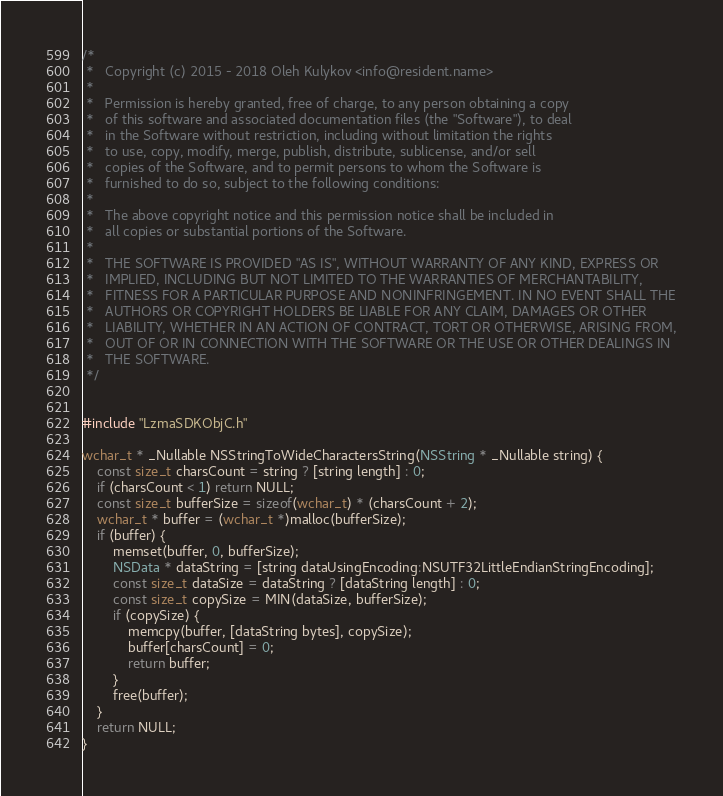<code> <loc_0><loc_0><loc_500><loc_500><_ObjectiveC_>/*
 *   Copyright (c) 2015 - 2018 Oleh Kulykov <info@resident.name>
 *
 *   Permission is hereby granted, free of charge, to any person obtaining a copy
 *   of this software and associated documentation files (the "Software"), to deal
 *   in the Software without restriction, including without limitation the rights
 *   to use, copy, modify, merge, publish, distribute, sublicense, and/or sell
 *   copies of the Software, and to permit persons to whom the Software is
 *   furnished to do so, subject to the following conditions:
 *
 *   The above copyright notice and this permission notice shall be included in
 *   all copies or substantial portions of the Software.
 *
 *   THE SOFTWARE IS PROVIDED "AS IS", WITHOUT WARRANTY OF ANY KIND, EXPRESS OR
 *   IMPLIED, INCLUDING BUT NOT LIMITED TO THE WARRANTIES OF MERCHANTABILITY,
 *   FITNESS FOR A PARTICULAR PURPOSE AND NONINFRINGEMENT. IN NO EVENT SHALL THE
 *   AUTHORS OR COPYRIGHT HOLDERS BE LIABLE FOR ANY CLAIM, DAMAGES OR OTHER
 *   LIABILITY, WHETHER IN AN ACTION OF CONTRACT, TORT OR OTHERWISE, ARISING FROM,
 *   OUT OF OR IN CONNECTION WITH THE SOFTWARE OR THE USE OR OTHER DEALINGS IN
 *   THE SOFTWARE.
 */


#include "LzmaSDKObjC.h"

wchar_t * _Nullable NSStringToWideCharactersString(NSString * _Nullable string) {
	const size_t charsCount = string ? [string length] : 0;
	if (charsCount < 1) return NULL;
	const size_t bufferSize = sizeof(wchar_t) * (charsCount + 2);
	wchar_t * buffer = (wchar_t *)malloc(bufferSize);
	if (buffer) {
		memset(buffer, 0, bufferSize);
		NSData * dataString = [string dataUsingEncoding:NSUTF32LittleEndianStringEncoding];
		const size_t dataSize = dataString ? [dataString length] : 0;
		const size_t copySize = MIN(dataSize, bufferSize);
		if (copySize) {
			memcpy(buffer, [dataString bytes], copySize);
			buffer[charsCount] = 0;
			return buffer;
		}
		free(buffer);
	}
	return NULL;
}
</code> 